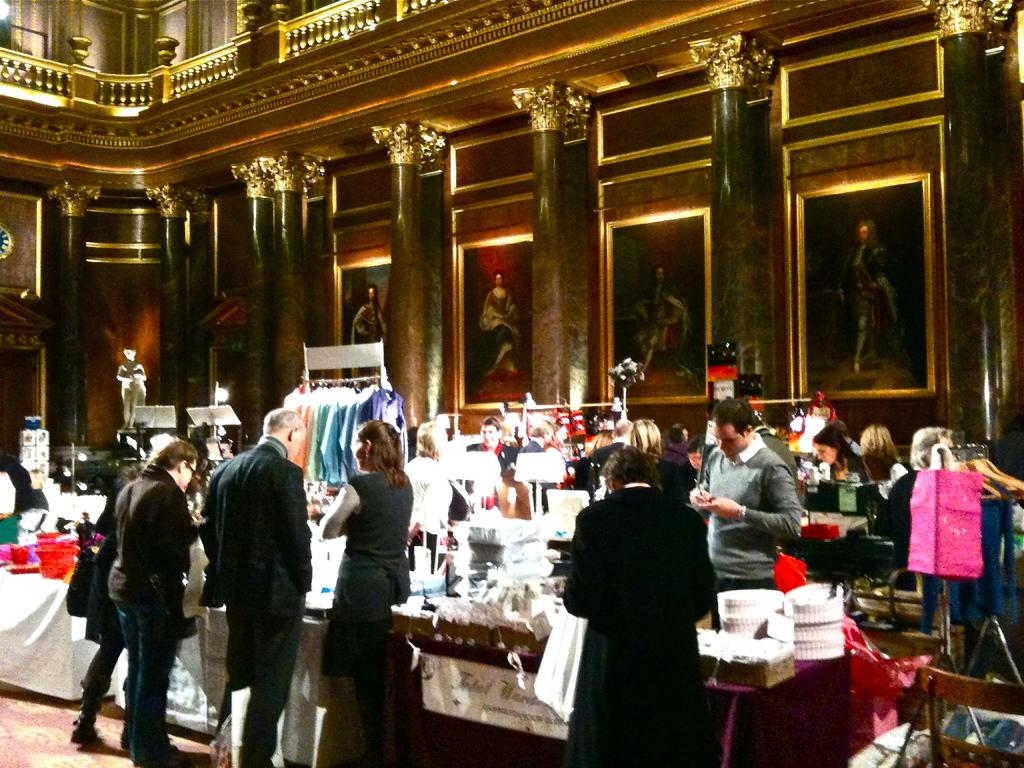What can be seen in the image? There are people standing in the image, and there are stalls present. What is visible in the background of the image? In the background, there are photo frames and pillars. What is at the bottom of the image? There is a carpet at the bottom of the image. Can you see a carpenter working on a project in the image? There is no carpenter visible in the image. 